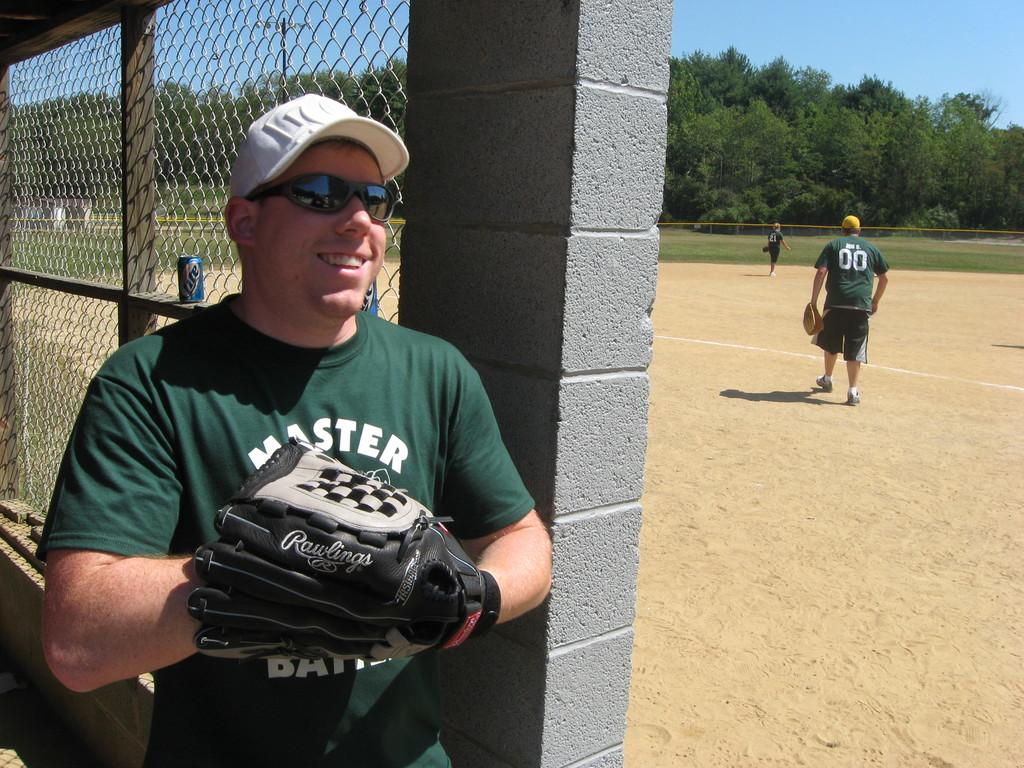What is the player's number?
Keep it short and to the point. 00. What brand of baseball glove is the man wearing?
Ensure brevity in your answer.  Rawlings. 